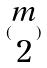Convert formula to latex. <formula><loc_0><loc_0><loc_500><loc_500>( \begin{matrix} m \\ 2 \end{matrix} )</formula> 